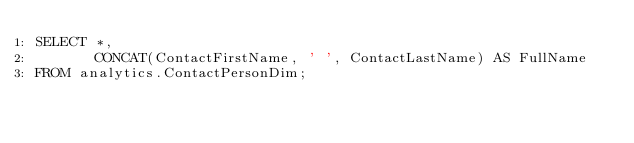Convert code to text. <code><loc_0><loc_0><loc_500><loc_500><_SQL_>SELECT *,
       CONCAT(ContactFirstName, ' ', ContactLastName) AS FullName
FROM analytics.ContactPersonDim;</code> 